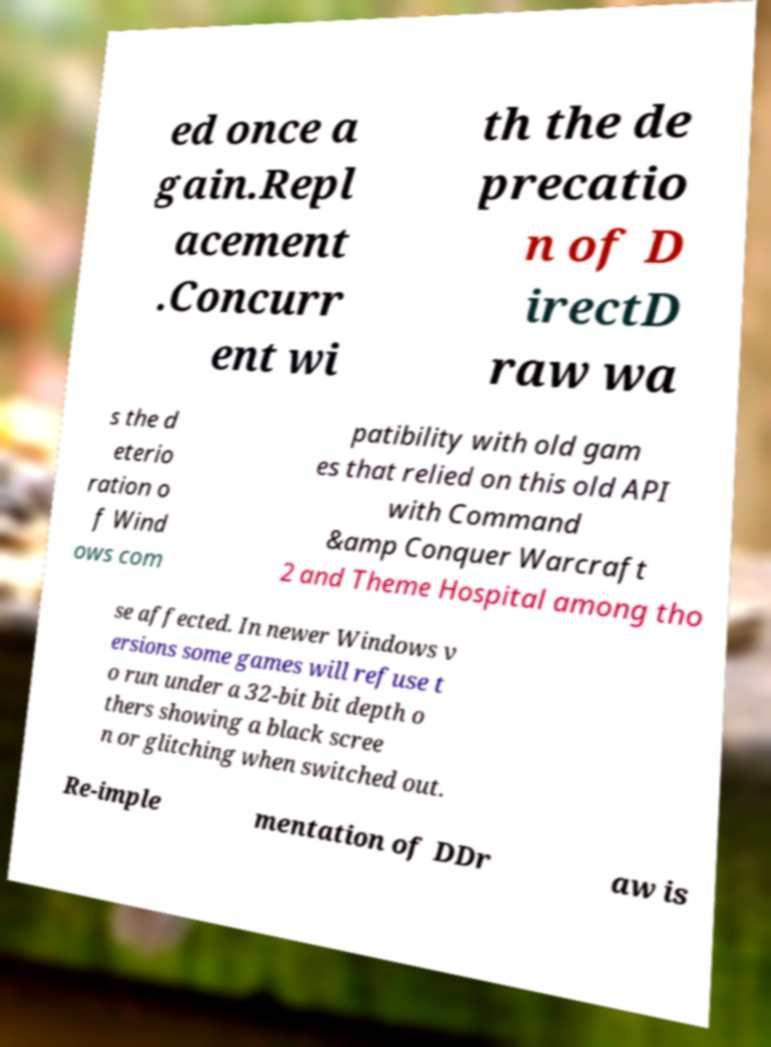I need the written content from this picture converted into text. Can you do that? ed once a gain.Repl acement .Concurr ent wi th the de precatio n of D irectD raw wa s the d eterio ration o f Wind ows com patibility with old gam es that relied on this old API with Command &amp Conquer Warcraft 2 and Theme Hospital among tho se affected. In newer Windows v ersions some games will refuse t o run under a 32-bit bit depth o thers showing a black scree n or glitching when switched out. Re-imple mentation of DDr aw is 